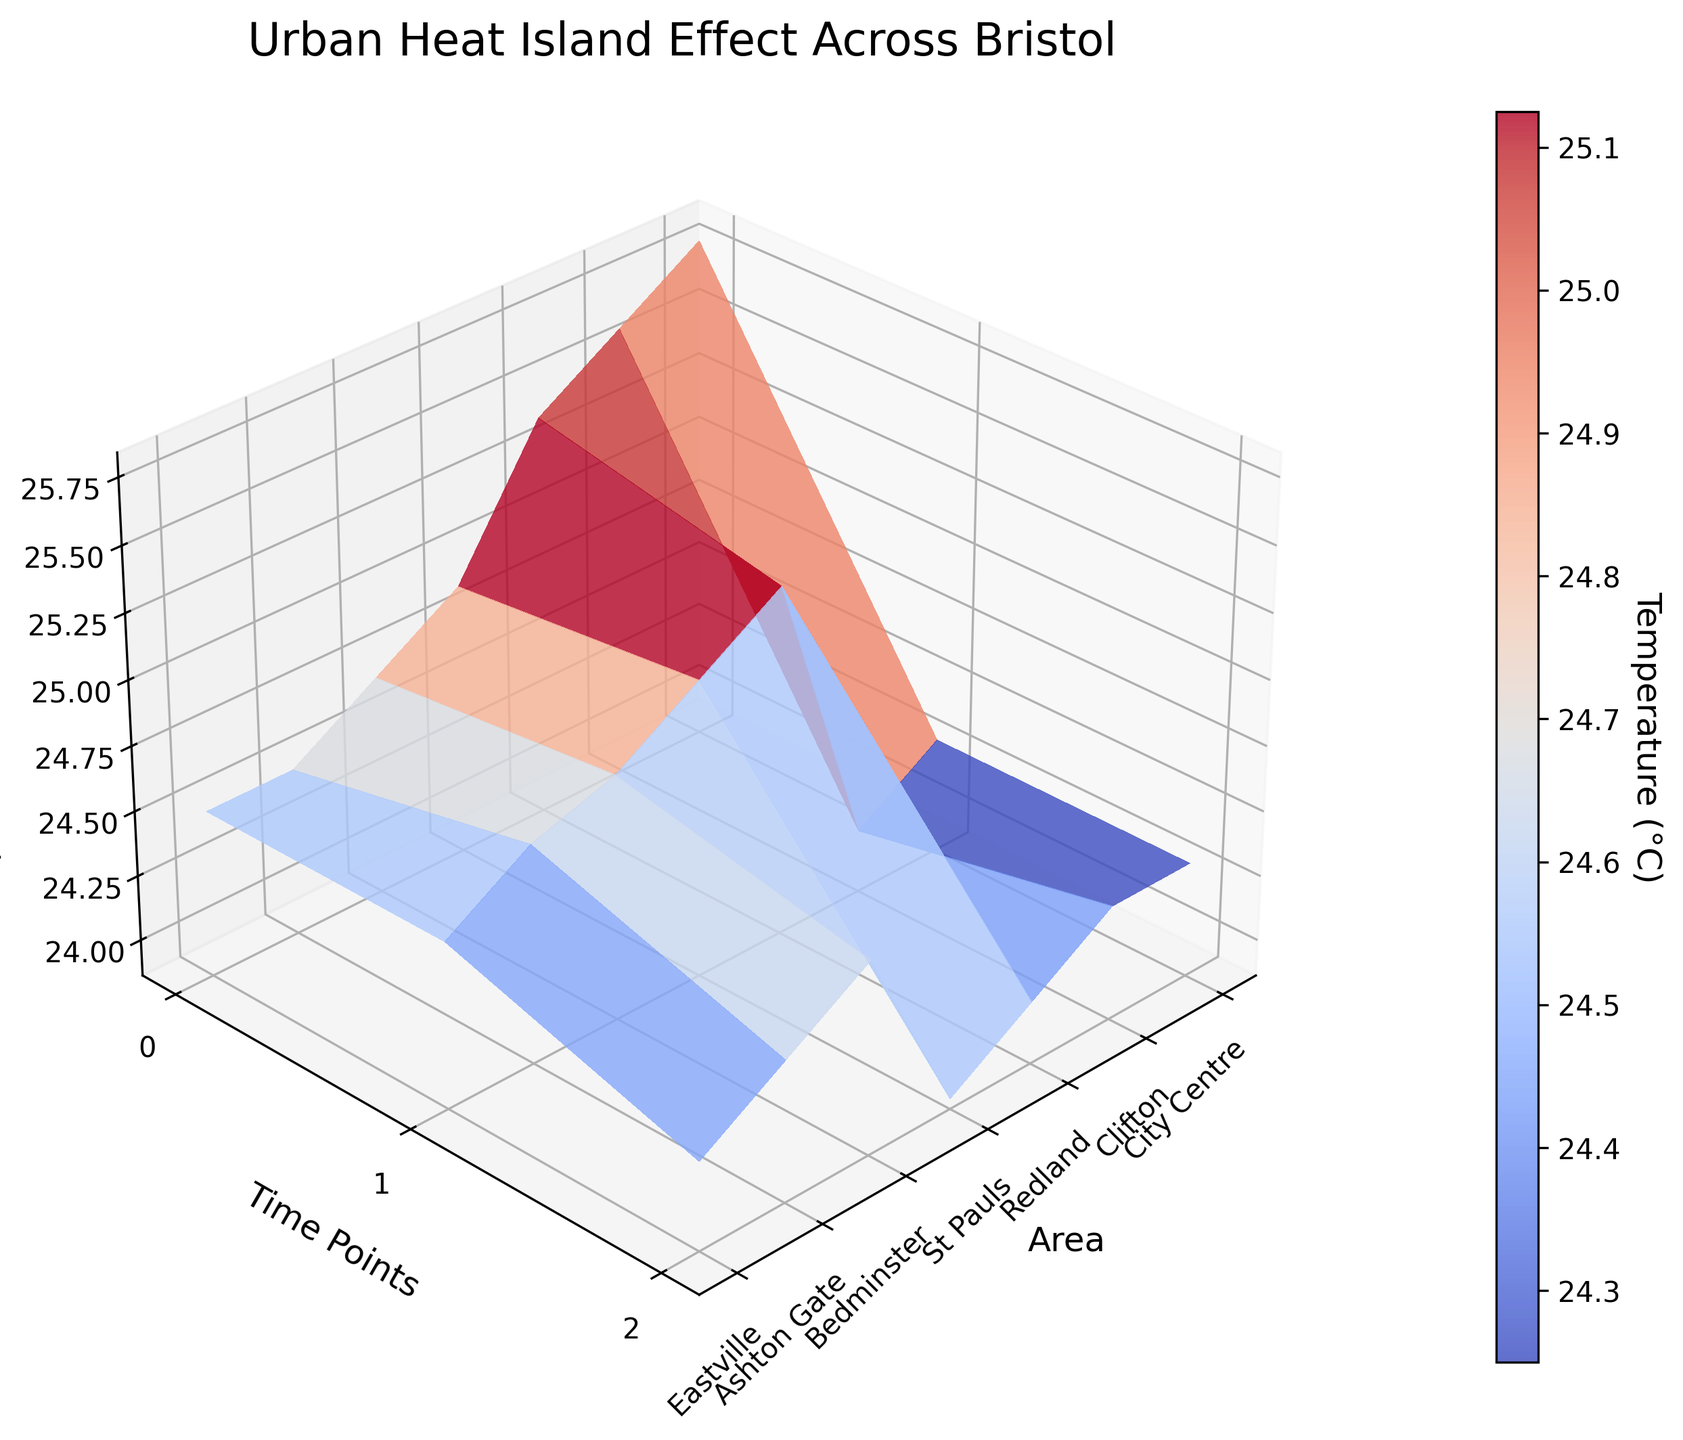What is the title of the 3D surface plot? Look at the top of the plot where the title is displayed. It reads "Urban Heat Island Effect Across Bristol".
Answer: Urban Heat Island Effect Across Bristol What is the temperature range in the plot? Examine the colorbar next to the plot that shows the range of temperatures. It ranges from approximately 23.9°C to 25.8°C.
Answer: 23.9°C to 25.8°C Which area has the highest temperature at time point 0? Observe the temperature values for each area at time point 0 (the front edge of the surface). City Centre has the highest temperature, which is 25.8°C.
Answer: City Centre How does the temperature change over time in Ashton Gate? Examine the surface plot along the x-axis for "Ashton Gate". The temperature decreases from 24.3°C at time point 0 to 23.9°C at time point 2.
Answer: Decreases Which area shows the least temperature variation across time points? Compare the variation in temperatures across the different time points for each area. "Redland" shows the smallest change, ranging from 24.5°C to 24.1°C.
Answer: Redland How does the temperature of City Centre at time point 2 compare with Clifton at time point 0? Locate both points on the plot and compare their Z-values. City Centre at time point 2 has a temperature of 25.4°C, while Clifton at time point 0 has a temperature of 24.9°C. Therefore, City Centre has a higher temperature.
Answer: City Centre is higher What trend do the temperatures in St Pauls show over the three time points? Look at the surface plot along the x-axis for "St Pauls". The temperature gradually decreases from 25.2°C at time point 0 to 24.8°C at time point 2.
Answer: Gradually decreases On average, does Bedminster have higher or lower temperatures compared to Eastville? Calculate the average temperature for both areas. Bedminster: (24.7°C + 24.5°C + 24.3°C) / 3 ≈ 24.5°C. Eastville: (24.6°C + 24.4°C + 24.2°C) / 3 ≈ 24.4°C. Therefore, Bedminster has a slightly higher average temperature.
Answer: Higher Which area shows the steepest decline in temperature from time point 0 to time point 2? Compare the temperature drops for each area from time point 0 to time point 2. Ashton Gate shows the steepest decline from 24.3°C to 23.9°C, a drop of 0.4°C.
Answer: Ashton Gate 